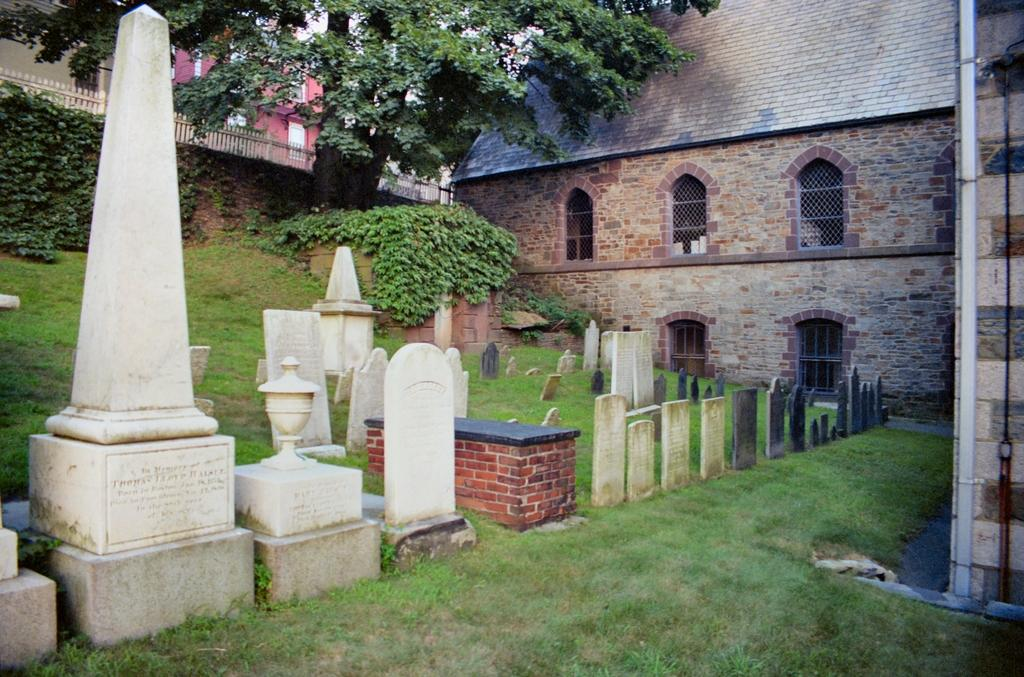What type of vegetation is at the bottom of the image? There is grass at the bottom of the image. What can be seen in the background of the image? There are trees and buildings in the background of the image. What type of shade is provided by the trees in the image? There is no mention of shade in the image, as it only describes the presence of trees and buildings in the background. 